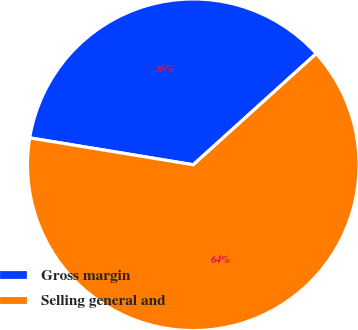<chart> <loc_0><loc_0><loc_500><loc_500><pie_chart><fcel>Gross margin<fcel>Selling general and<nl><fcel>35.71%<fcel>64.29%<nl></chart> 